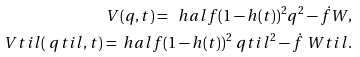Convert formula to latex. <formula><loc_0><loc_0><loc_500><loc_500>V ( q , t ) = \ h a l f ( 1 - h ( t ) ) ^ { 2 } q ^ { 2 } - \dot { f } W , \\ \ V t i l ( \ q t i l , t ) = \ h a l f ( 1 - h ( t ) ) ^ { 2 } \ q t i l ^ { 2 } - \dot { f } \ W t i l .</formula> 